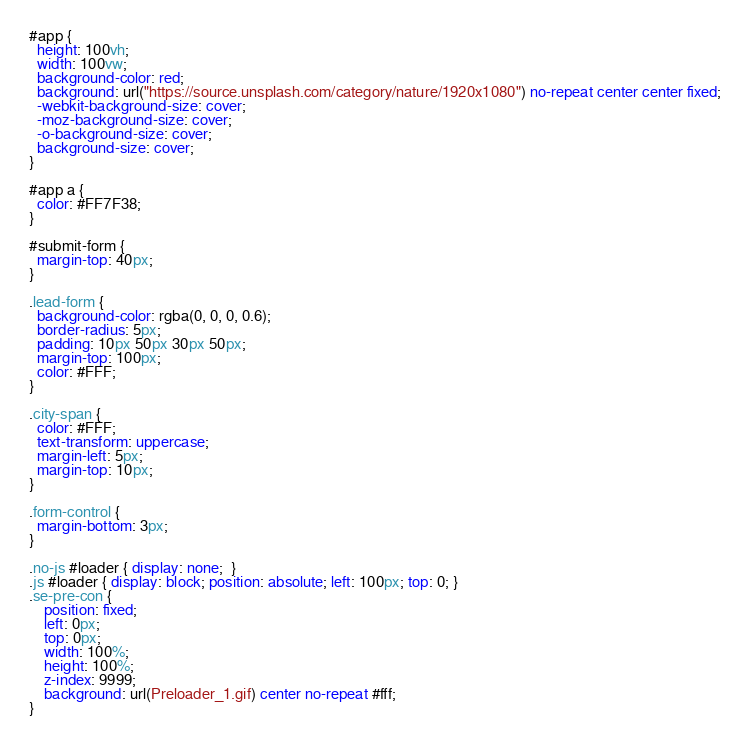Convert code to text. <code><loc_0><loc_0><loc_500><loc_500><_CSS_>#app {
  height: 100vh;
  width: 100vw;
  background-color: red;
  background: url("https://source.unsplash.com/category/nature/1920x1080") no-repeat center center fixed;
  -webkit-background-size: cover;
  -moz-background-size: cover;
  -o-background-size: cover;
  background-size: cover;
}

#app a {
  color: #FF7F38;
}

#submit-form {
  margin-top: 40px;
}

.lead-form {
  background-color: rgba(0, 0, 0, 0.6);
  border-radius: 5px;
  padding: 10px 50px 30px 50px;
  margin-top: 100px;
  color: #FFF;
}

.city-span {
  color: #FFF;
  text-transform: uppercase;
  margin-left: 5px;
  margin-top: 10px;
}

.form-control {
  margin-bottom: 3px;
}

.no-js #loader { display: none;  }
.js #loader { display: block; position: absolute; left: 100px; top: 0; }
.se-pre-con {
	position: fixed;
	left: 0px;
	top: 0px;
	width: 100%;
	height: 100%;
	z-index: 9999;
	background: url(Preloader_1.gif) center no-repeat #fff;
}
</code> 